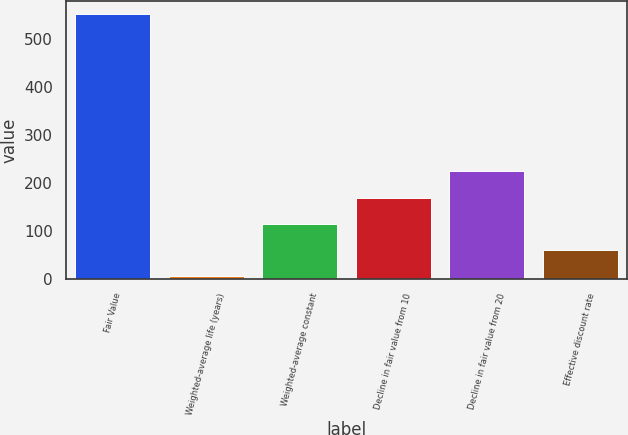Convert chart to OTSL. <chart><loc_0><loc_0><loc_500><loc_500><bar_chart><fcel>Fair Value<fcel>Weighted-average life (years)<fcel>Weighted-average constant<fcel>Decline in fair value from 10<fcel>Decline in fair value from 20<fcel>Effective discount rate<nl><fcel>552<fcel>5.3<fcel>114.64<fcel>169.31<fcel>223.98<fcel>59.97<nl></chart> 